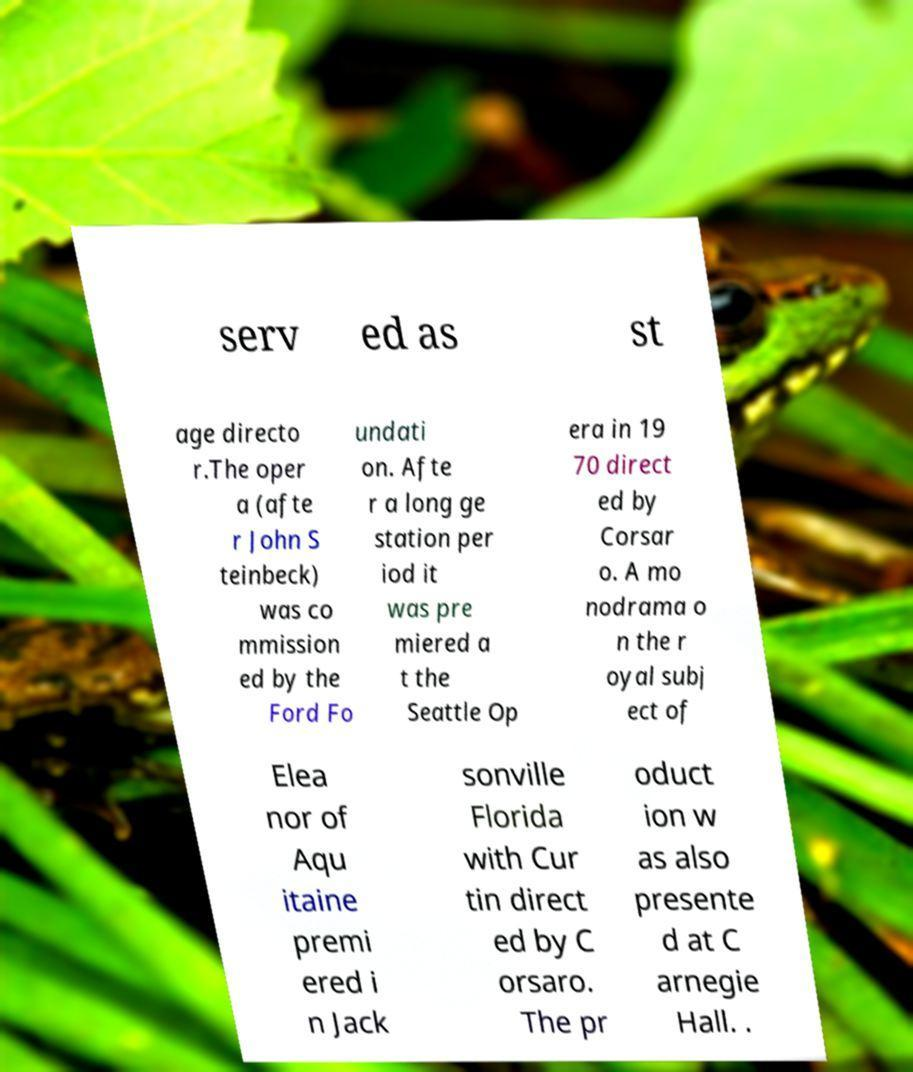Could you extract and type out the text from this image? serv ed as st age directo r.The oper a (afte r John S teinbeck) was co mmission ed by the Ford Fo undati on. Afte r a long ge station per iod it was pre miered a t the Seattle Op era in 19 70 direct ed by Corsar o. A mo nodrama o n the r oyal subj ect of Elea nor of Aqu itaine premi ered i n Jack sonville Florida with Cur tin direct ed by C orsaro. The pr oduct ion w as also presente d at C arnegie Hall. . 